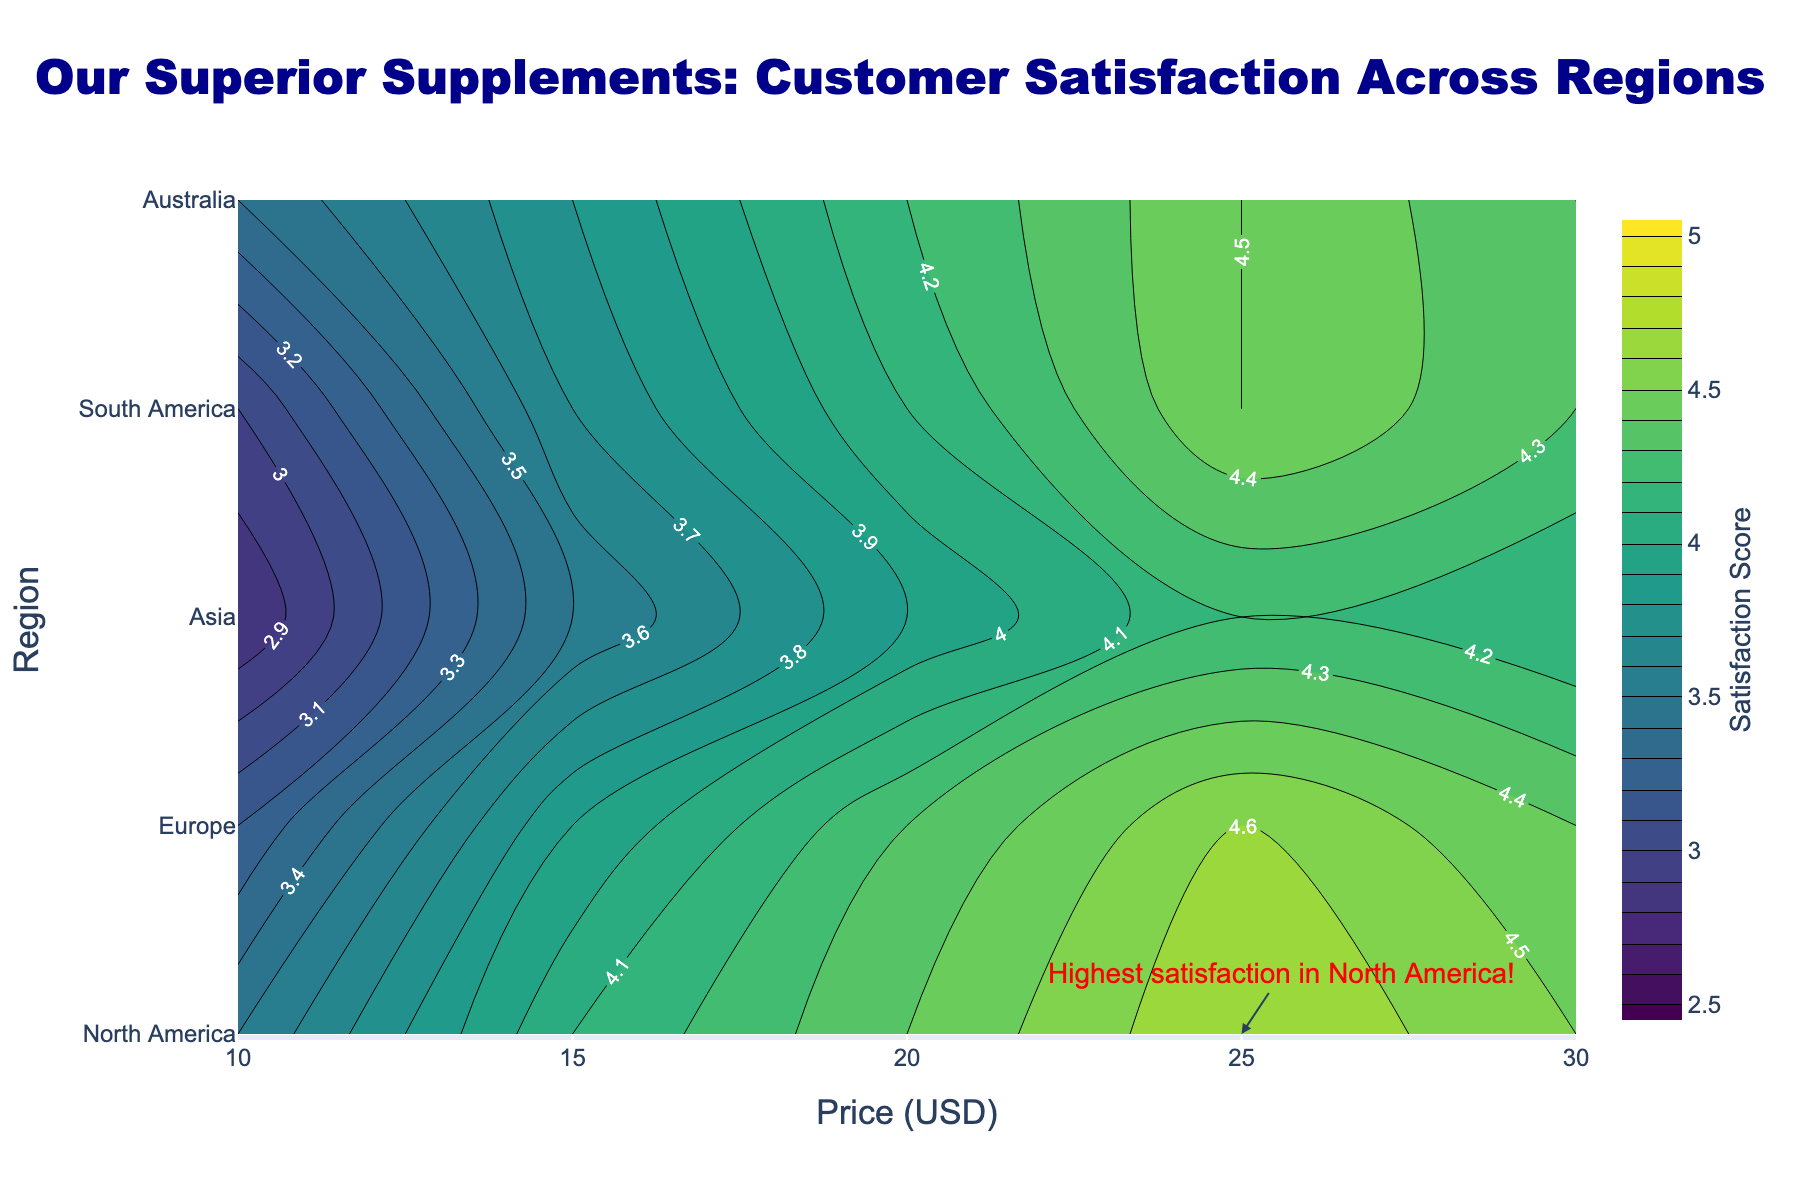What is the title of the figure? The title is at the top center of the figure and reads "Our Superior Supplements: Customer Satisfaction Across Regions".
Answer: Our Superior Supplements: Customer Satisfaction Across Regions What is represented on the x-axis and y-axis? The x-axis is labeled "Price (USD)" and the y-axis is labeled "Region".
Answer: Price (USD) and Region Which region has the highest customer satisfaction score at a price point of $25? The annotation on the plot indicates the highest satisfaction score is in North America at this price point.
Answer: North America How does the customer satisfaction score change with price in Europe? By following the contour lines in Europe, the score starts at 3.2 at $10, increases to 3.9 at $15, 4.3 at $20, 4.6 at $25, and then slightly decreases to 4.4 at $30.
Answer: It generally increases from 3.2 to 4.6, then slightly decreases to 4.4 Which region has the lowest satisfaction score at the lowest price point? By observing the contour lines at the $10 price point, Asia has the lowest score of 2.8 compared to other regions.
Answer: Asia Is there a region where the customer satisfaction score decreases with increasing price? No region shows a consistent decrease in satisfaction scores with increasing price; most regions exhibit an increase or plateau.
Answer: No Compare the satisfaction score at $20 between Asia and Australia. Which one is higher? The contour lines show Asia has a score of 3.9 at $20, while Australia has a score of 4.2.
Answer: Australia What is the general trend of satisfaction scores in South America as price increases? Following the contour lines for South America, the scores increase from 3.0 at $10 to 4.5 at $25 and then slightly decrease to 4.3 at $30.
Answer: Generally increasing On average, which region has the highest satisfaction scores across all price points? North America consistently shows high satisfaction scores across all price points, indicating a higher average score.
Answer: North America What color represents the highest satisfaction score in the figure? The highest satisfaction scores are represented by the darkest shades in the Viridis color scale, which are dark green to almost black.
Answer: Dark green to black 